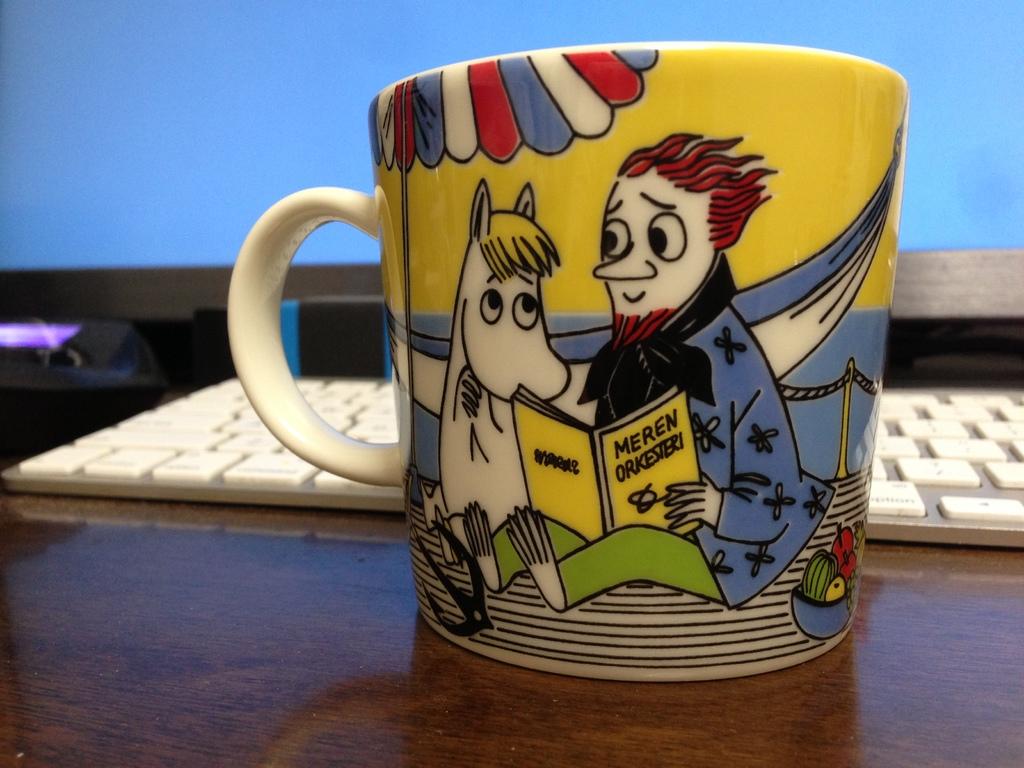What book is the man reading on the mug?
Make the answer very short. Meren orkesteri. 